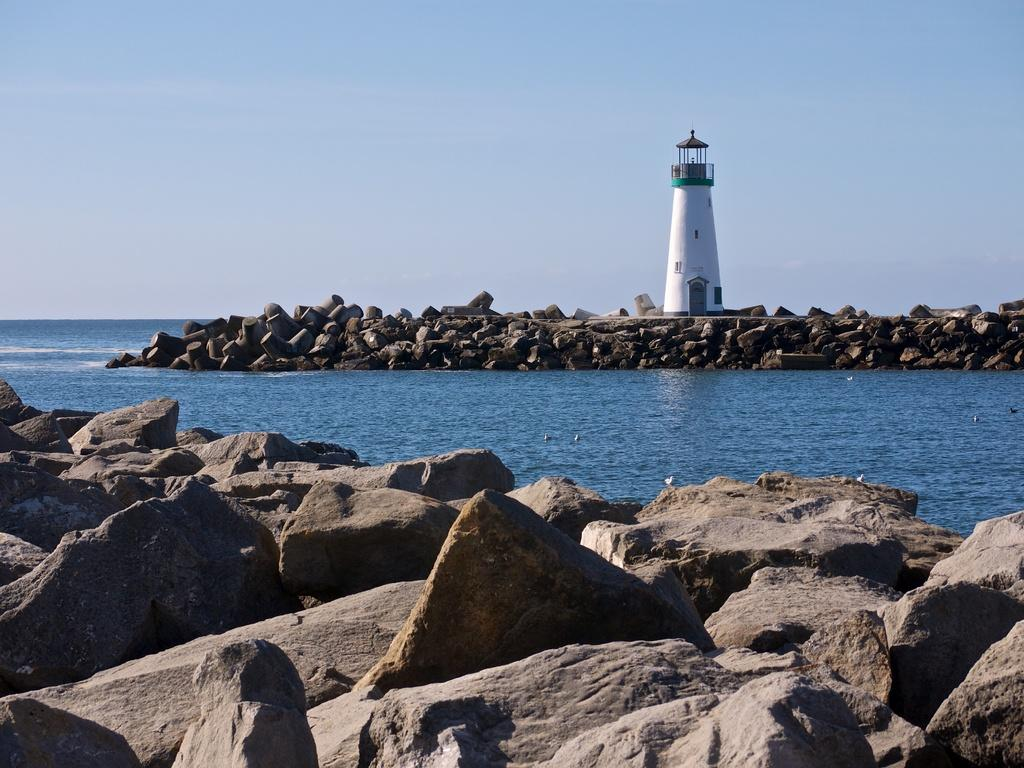What is in the foreground of the picture? There are stones in the foreground of the picture. What can be seen in the center of the picture? There are stones, a lighthouse, and water in the center of the picture. What is the condition of the sky in the picture? The sky is clear in the picture. What is the weather like in the image? It is sunny in the image. What type of carriage can be seen in the picture? There is no carriage present in the picture; it features stones, a lighthouse, and water. What design elements can be observed in the stones in the picture? The stones in the picture do not have any specific design elements; they are natural rocks. 